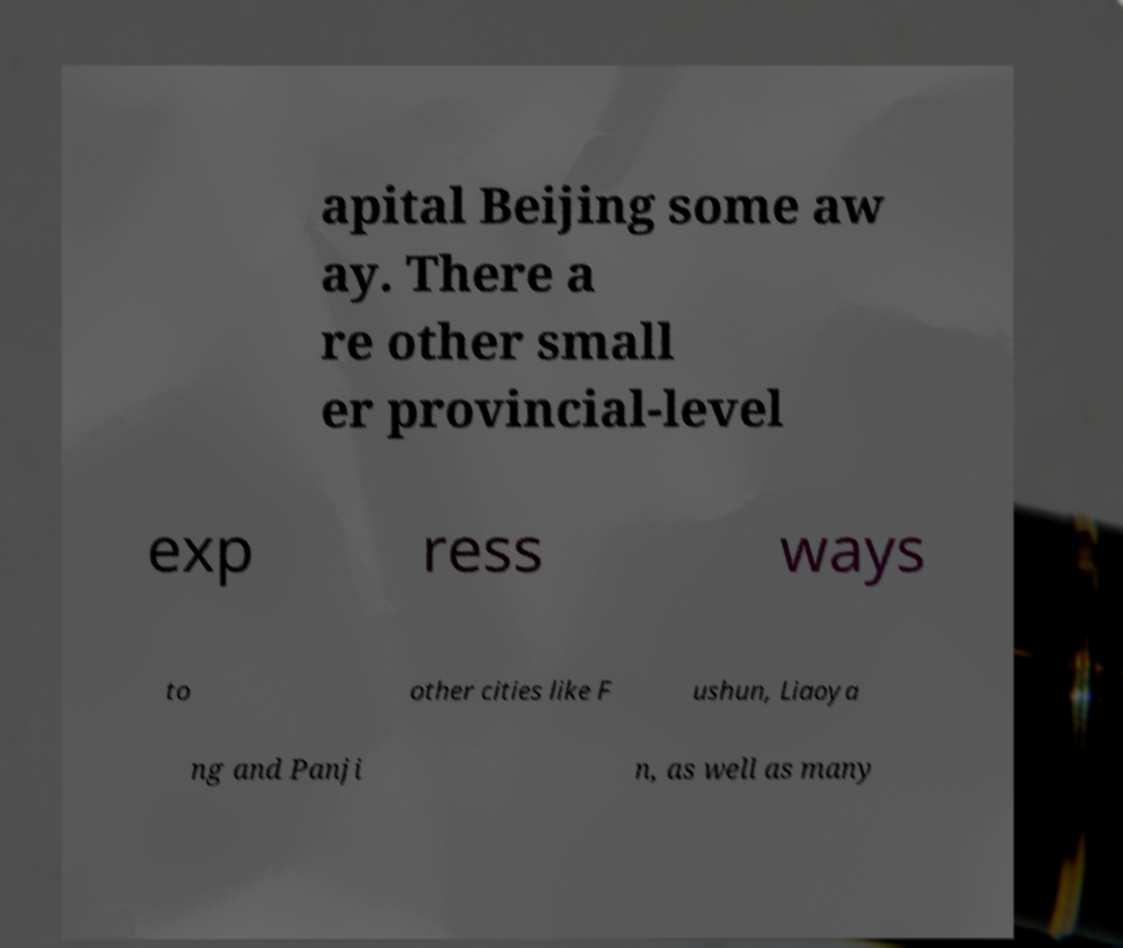I need the written content from this picture converted into text. Can you do that? apital Beijing some aw ay. There a re other small er provincial-level exp ress ways to other cities like F ushun, Liaoya ng and Panji n, as well as many 